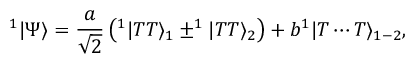Convert formula to latex. <formula><loc_0><loc_0><loc_500><loc_500>^ { 1 } | \Psi \rangle = \frac { a } { \sqrt { 2 } } \left ( ^ { 1 } | T T \rangle _ { 1 } \pm ^ { 1 } | T T \rangle _ { 2 } \right ) + b ^ { 1 } | T \cdots T \rangle _ { 1 - 2 } ,</formula> 